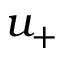Convert formula to latex. <formula><loc_0><loc_0><loc_500><loc_500>u _ { + }</formula> 